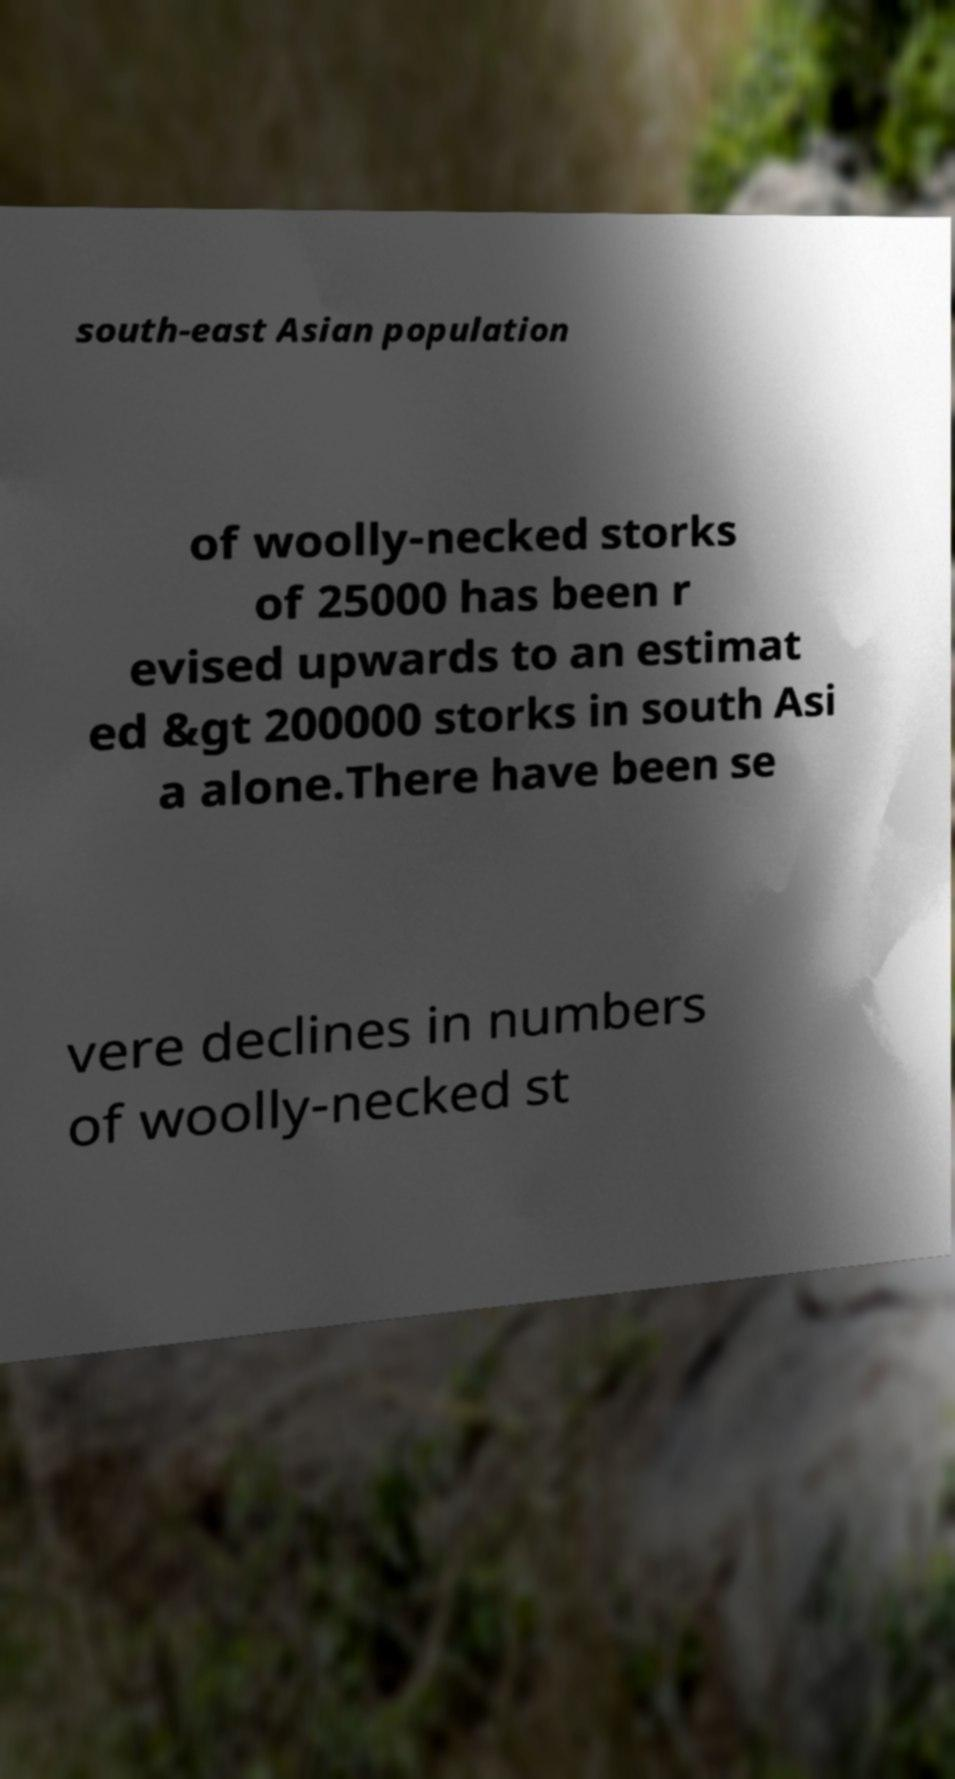Please identify and transcribe the text found in this image. south-east Asian population of woolly-necked storks of 25000 has been r evised upwards to an estimat ed &gt 200000 storks in south Asi a alone.There have been se vere declines in numbers of woolly-necked st 